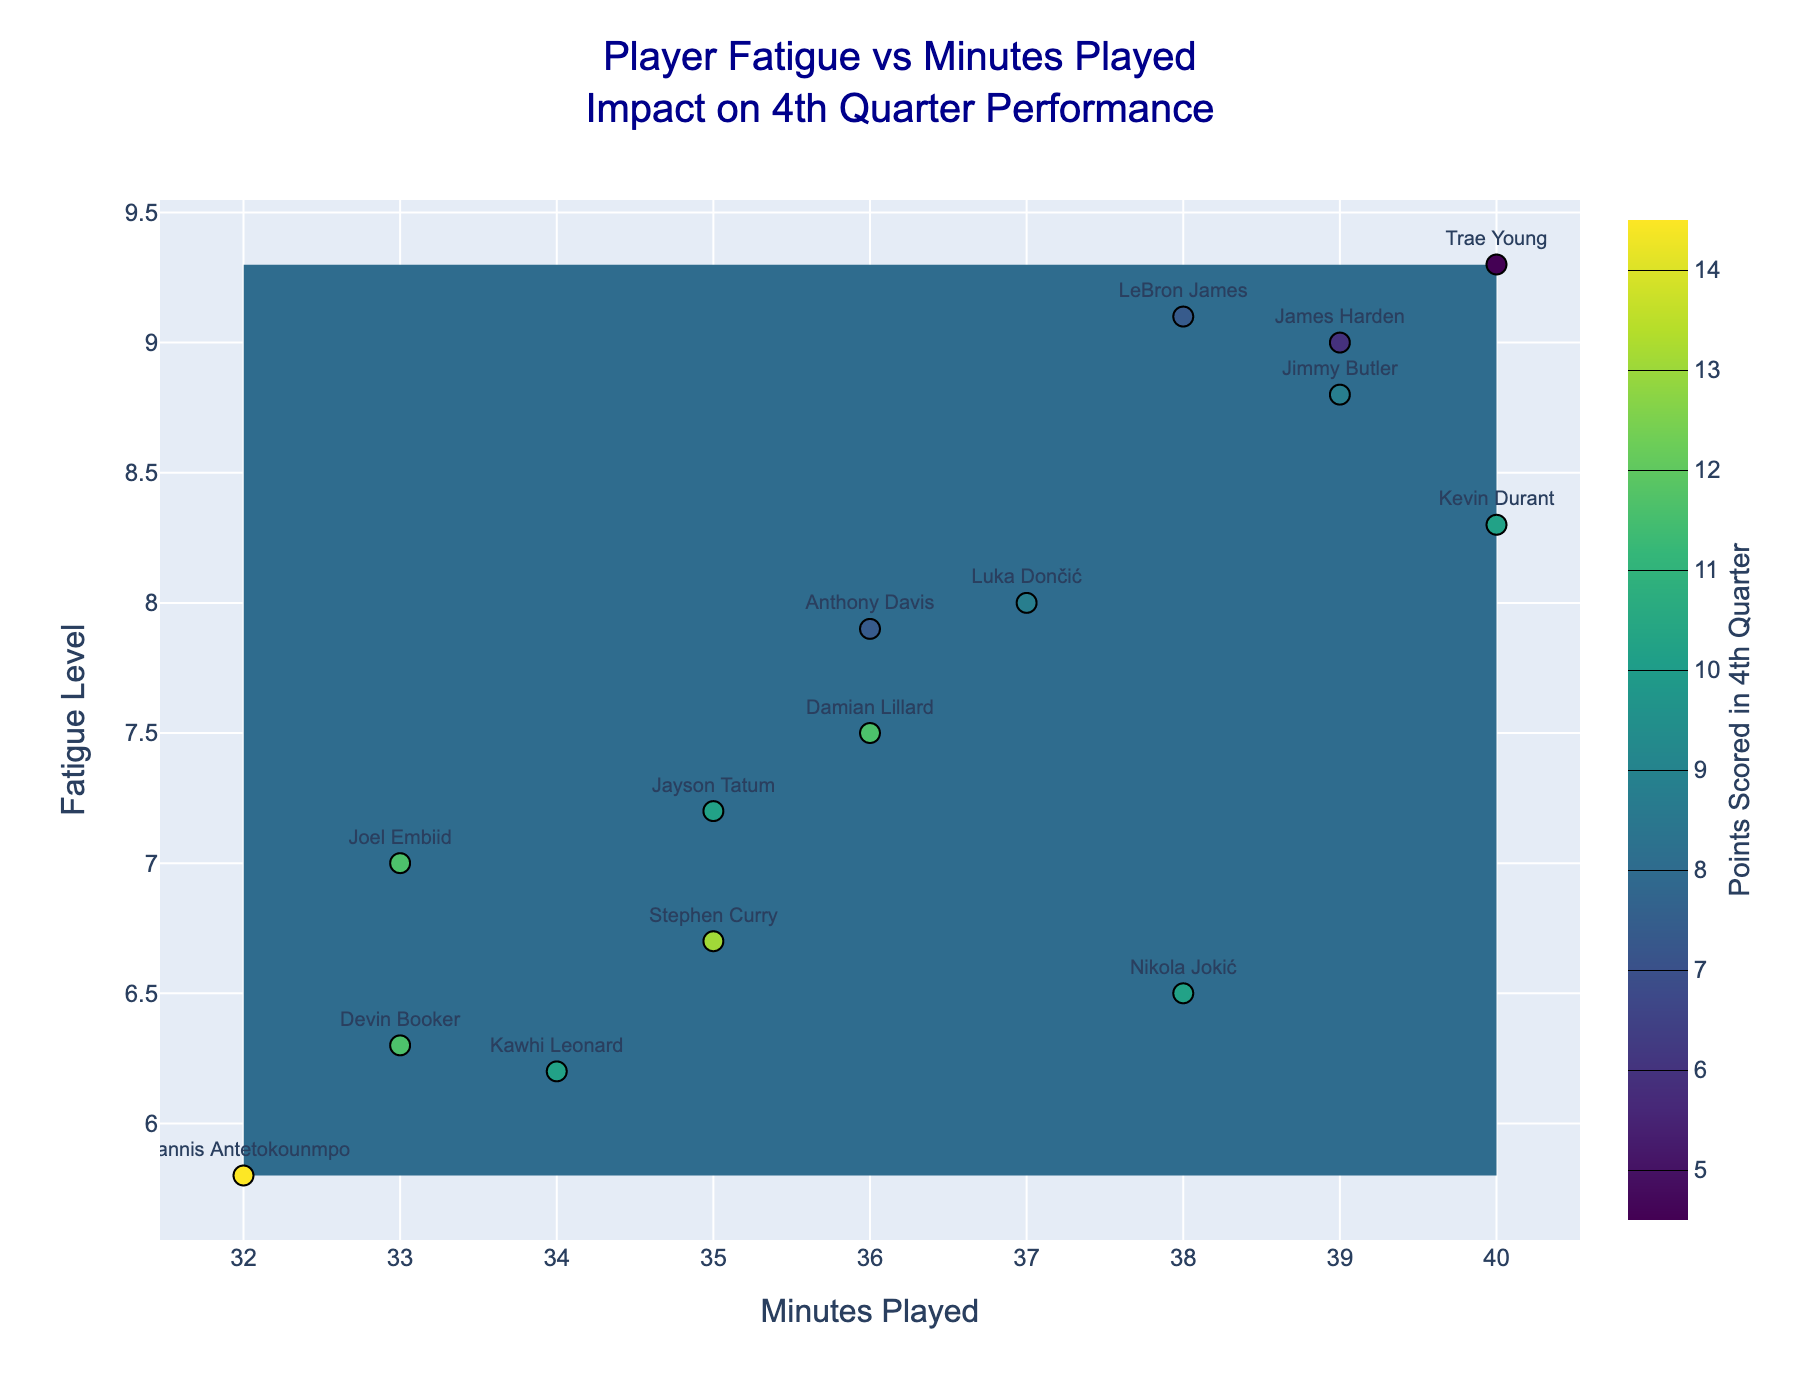How many players have a fatigue level above 8? By looking at the scatter points and identifying those with fatigue levels above the value of 8 on the y-axis, we can find the number of corresponding points.
Answer: 5 What is the relationship between minutes played and fatigue level for the players? From the scatter plot, observe the general trend of the points plotted which reflect player performance based on both the x-axis (minutes played) and the y-axis (fatigue level).
Answer: Players with higher minutes tend to have higher fatigue levels What is the contour interval for this plot? By examining the contour lines and noting the color changes, we can see the intervals are evenly spaced between the points scored, as stated in the legend, starting at 5 and ending at 14 with an interval size of 1.
Answer: 1 Which player played the most minutes and what were their points scored in the 4th quarter? The scatter point farthest to the right on the x-axis represents the player with the most minutes played. Hover over/label shows the player name and their corresponding points scored.
Answer: Trae Young, 6 points What range of fatigue levels corresponds to the highest points scored in the fourth quarter? By observing the contour colors correlating to the highest points (13-14), and checking the corresponding y-axis values, we can see which range of fatigue levels falls into the higher point category.
Answer: 5.8 to 6.7 Which player scored the most points in the fourth quarter and what was their fatigue level? By locating the deepest contour color or the highest label in the figure and identifying the corresponding scatter point, we determine the player's details.
Answer: Giannis Antetokounmpo, 5.8 What do the contour lines represent in this plot? Contour lines in a 2D contour plot represent different levels of points scored in the fourth quarter achieved by players based on their minutes played and fatigue levels.
Answer: Points scored in the 4th quarter How do minutes played affect the variability in points scored in the 4th quarter across different fatigue levels? By analyzing the spread of contour lines horizontally across different minutes played (x-axis), observe the variation in points scored as the fatigue levels change.
Answer: Higher minutes tend to show higher fatigue and varied points scored Between which two players is there the greatest difference in fatigue level despite similar minutes played? Compare positions of scatter points with close x-values (similar minutes played) but differing y-values (fatigue levels) to identify the two players.
Answer: James Harden and Nikola Jokić Which contour color range corresponds to the lowest points in the 4th quarter and what is the range of minutes played and fatigue levels within this contour? The contour color associated with the lowest points (5-6) will indicate the range, controlled in the heatmap as stated in the legend. Check what values on the x and y axes fall into this range.
Answer: Minutes played: 35-40, Fatigue levels: 9.0-9.3 